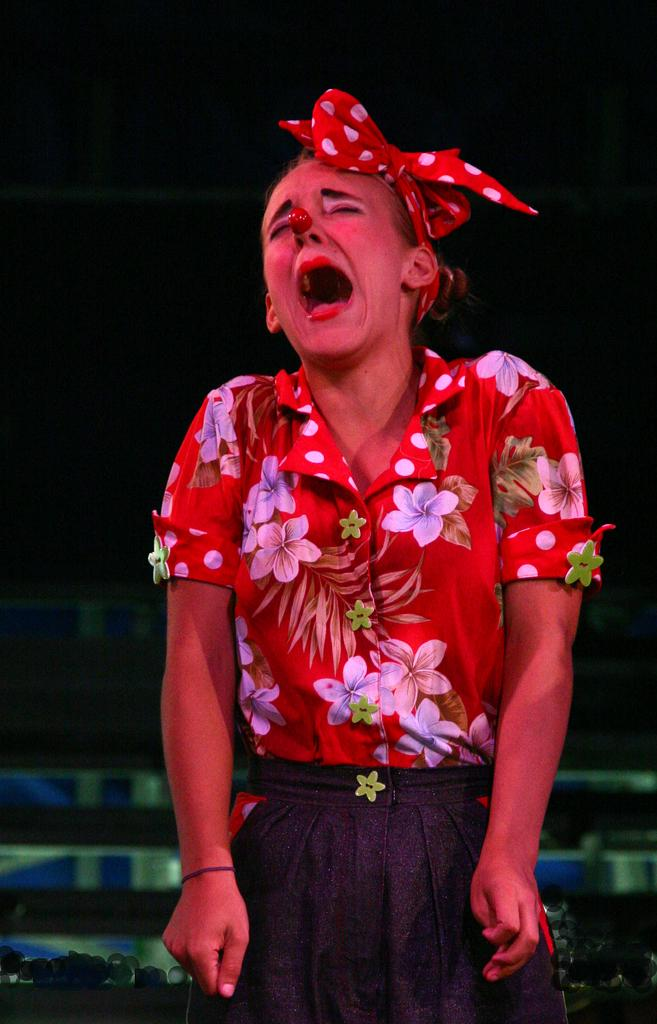Who is present in the image? There is a woman in the image. What is the woman doing in the image? The woman is crying. What can be seen on the woman's head? The woman is wearing a hairband. How would you describe the background of the image? The background of the image has a dark view. What type of robin can be seen perched on the woman's shoulder in the image? There is no robin present in the image; it only features a woman. What color is the silver object in the woman's hand in the image? There is no silver object present in the woman's hand in the image. 